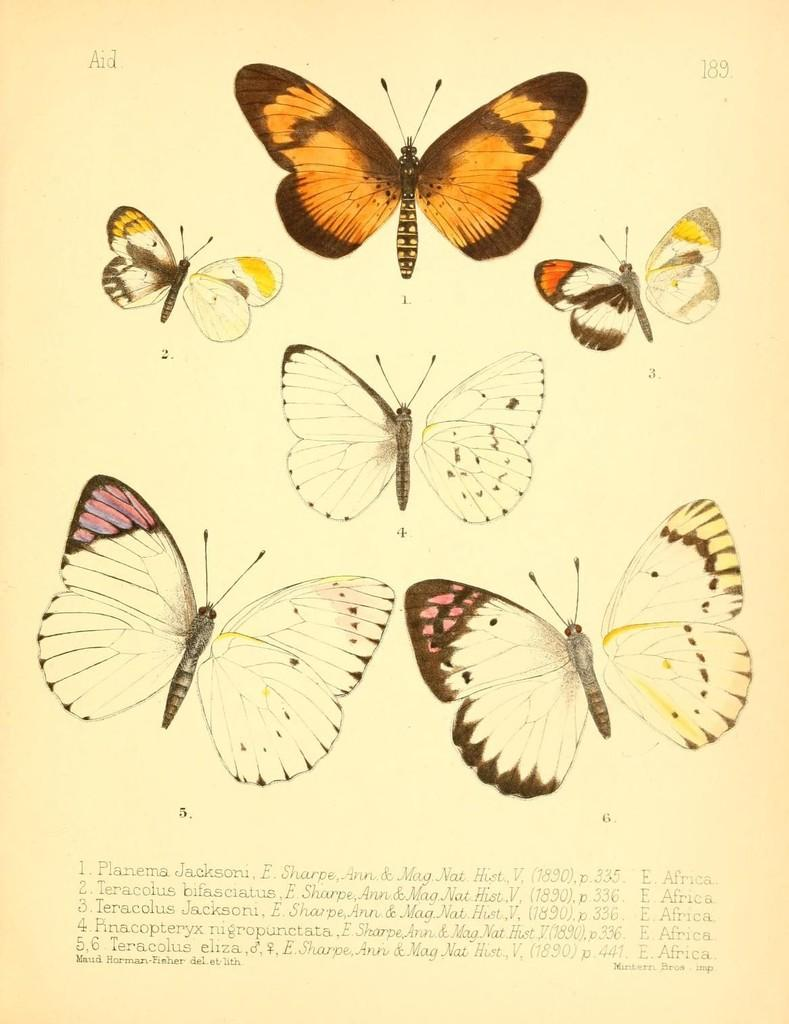What is the primary material of the image? The image is a paper. What type of images can be seen on the paper? There are pictures of butterflies on the paper. What type of seat is visible in the image? There is no seat present in the image; it is a paper with pictures of butterflies. What type of tools might a carpenter use in the image? There is no carpenter or tools present in the image; it is a paper with pictures of butterflies. 